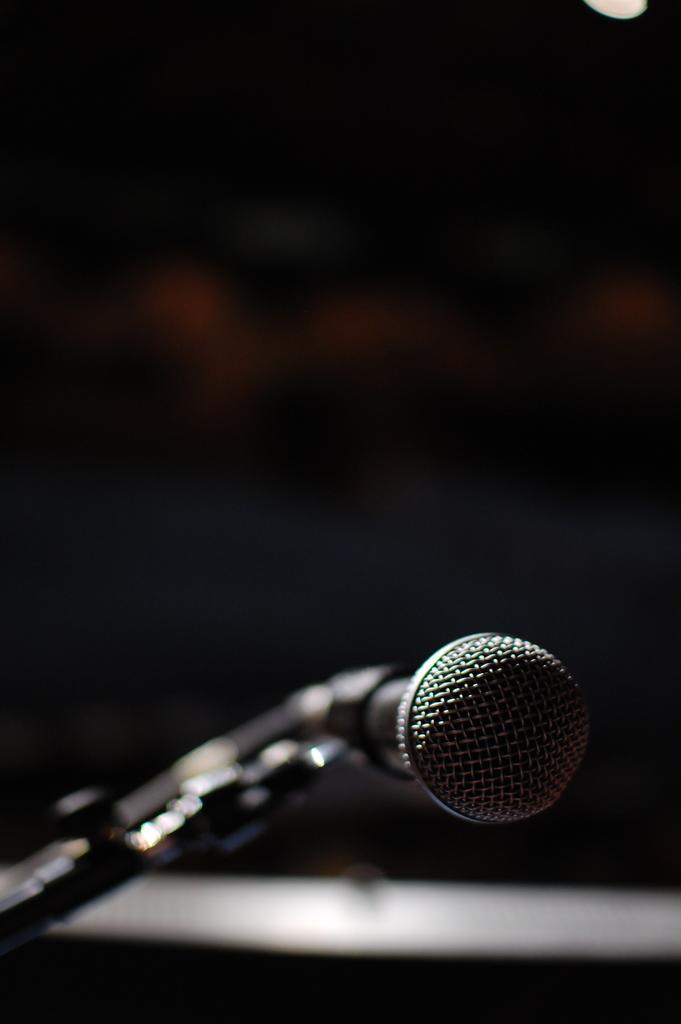In one or two sentences, can you explain what this image depicts? In this image I can see a mile which is attached to a metal stand. The background is in black color. 